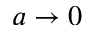Convert formula to latex. <formula><loc_0><loc_0><loc_500><loc_500>a \to 0</formula> 